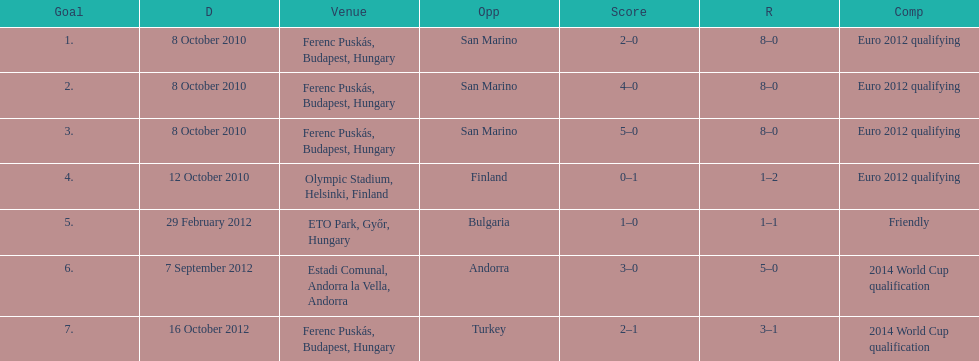What is the complete sum of international goals ádám szalai has achieved? 7. 